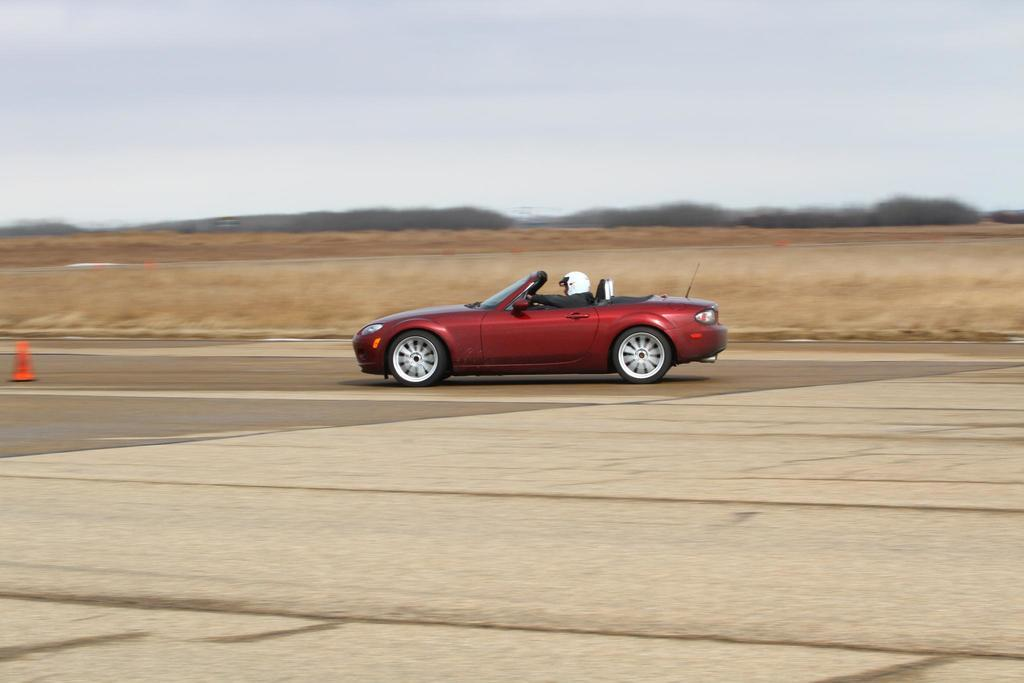What is the person in the image doing? The person is riding a car in the image. Where is the car located? The car is on the road. What object can be seen near the car? There is a traffic cone in the image. How would you describe the background of the image? The background of the image is blurry, but grass, trees, and the sky are visible. What type of fruit is being harvested in the image? There is no fruit being harvested in the image; it features a person riding a car on the road. What winter activity is taking place in the image? There is no winter activity present in the image; it is not focused on any seasonal activities. 